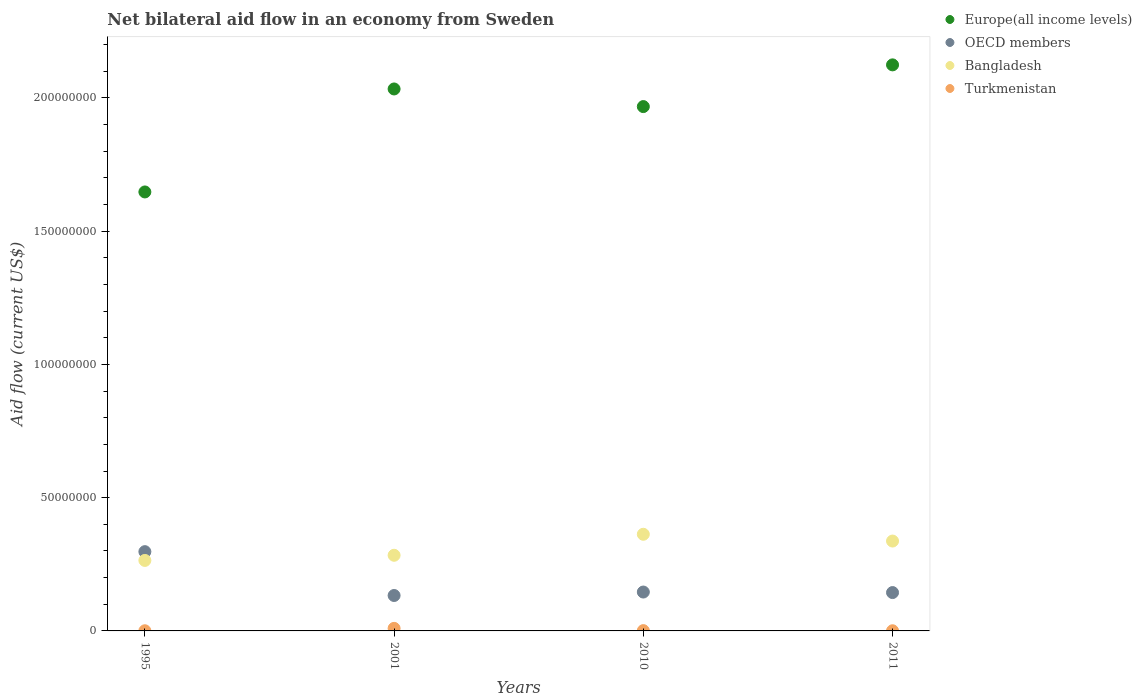Is the number of dotlines equal to the number of legend labels?
Give a very brief answer. Yes. What is the net bilateral aid flow in OECD members in 2010?
Make the answer very short. 1.46e+07. Across all years, what is the maximum net bilateral aid flow in Bangladesh?
Your answer should be very brief. 3.63e+07. Across all years, what is the minimum net bilateral aid flow in OECD members?
Give a very brief answer. 1.33e+07. What is the total net bilateral aid flow in Bangladesh in the graph?
Ensure brevity in your answer.  1.25e+08. What is the difference between the net bilateral aid flow in Europe(all income levels) in 1995 and that in 2010?
Your response must be concise. -3.20e+07. What is the difference between the net bilateral aid flow in Europe(all income levels) in 1995 and the net bilateral aid flow in OECD members in 2001?
Your response must be concise. 1.51e+08. What is the average net bilateral aid flow in OECD members per year?
Make the answer very short. 1.80e+07. In the year 2010, what is the difference between the net bilateral aid flow in Bangladesh and net bilateral aid flow in Turkmenistan?
Offer a terse response. 3.62e+07. What is the ratio of the net bilateral aid flow in Turkmenistan in 1995 to that in 2001?
Your response must be concise. 0.06. Is the net bilateral aid flow in Turkmenistan in 1995 less than that in 2001?
Keep it short and to the point. Yes. Is the difference between the net bilateral aid flow in Bangladesh in 2010 and 2011 greater than the difference between the net bilateral aid flow in Turkmenistan in 2010 and 2011?
Your answer should be compact. Yes. What is the difference between the highest and the second highest net bilateral aid flow in Europe(all income levels)?
Ensure brevity in your answer.  9.04e+06. What is the difference between the highest and the lowest net bilateral aid flow in Europe(all income levels)?
Provide a succinct answer. 4.77e+07. In how many years, is the net bilateral aid flow in Bangladesh greater than the average net bilateral aid flow in Bangladesh taken over all years?
Offer a terse response. 2. Is the sum of the net bilateral aid flow in OECD members in 2010 and 2011 greater than the maximum net bilateral aid flow in Bangladesh across all years?
Ensure brevity in your answer.  No. Is it the case that in every year, the sum of the net bilateral aid flow in Bangladesh and net bilateral aid flow in Europe(all income levels)  is greater than the net bilateral aid flow in OECD members?
Your answer should be compact. Yes. Is the net bilateral aid flow in OECD members strictly greater than the net bilateral aid flow in Bangladesh over the years?
Your response must be concise. No. How many dotlines are there?
Offer a terse response. 4. What is the difference between two consecutive major ticks on the Y-axis?
Keep it short and to the point. 5.00e+07. Where does the legend appear in the graph?
Ensure brevity in your answer.  Top right. How many legend labels are there?
Provide a succinct answer. 4. What is the title of the graph?
Ensure brevity in your answer.  Net bilateral aid flow in an economy from Sweden. What is the Aid flow (current US$) in Europe(all income levels) in 1995?
Offer a terse response. 1.65e+08. What is the Aid flow (current US$) of OECD members in 1995?
Your answer should be very brief. 2.97e+07. What is the Aid flow (current US$) in Bangladesh in 1995?
Make the answer very short. 2.64e+07. What is the Aid flow (current US$) of Europe(all income levels) in 2001?
Ensure brevity in your answer.  2.03e+08. What is the Aid flow (current US$) of OECD members in 2001?
Give a very brief answer. 1.33e+07. What is the Aid flow (current US$) of Bangladesh in 2001?
Ensure brevity in your answer.  2.84e+07. What is the Aid flow (current US$) of Turkmenistan in 2001?
Your response must be concise. 9.60e+05. What is the Aid flow (current US$) of Europe(all income levels) in 2010?
Your answer should be compact. 1.97e+08. What is the Aid flow (current US$) in OECD members in 2010?
Ensure brevity in your answer.  1.46e+07. What is the Aid flow (current US$) of Bangladesh in 2010?
Make the answer very short. 3.63e+07. What is the Aid flow (current US$) in Europe(all income levels) in 2011?
Keep it short and to the point. 2.12e+08. What is the Aid flow (current US$) in OECD members in 2011?
Offer a terse response. 1.44e+07. What is the Aid flow (current US$) of Bangladesh in 2011?
Provide a short and direct response. 3.37e+07. What is the Aid flow (current US$) of Turkmenistan in 2011?
Offer a terse response. 6.00e+04. Across all years, what is the maximum Aid flow (current US$) in Europe(all income levels)?
Your answer should be very brief. 2.12e+08. Across all years, what is the maximum Aid flow (current US$) in OECD members?
Your response must be concise. 2.97e+07. Across all years, what is the maximum Aid flow (current US$) in Bangladesh?
Give a very brief answer. 3.63e+07. Across all years, what is the maximum Aid flow (current US$) in Turkmenistan?
Give a very brief answer. 9.60e+05. Across all years, what is the minimum Aid flow (current US$) in Europe(all income levels)?
Offer a very short reply. 1.65e+08. Across all years, what is the minimum Aid flow (current US$) in OECD members?
Your response must be concise. 1.33e+07. Across all years, what is the minimum Aid flow (current US$) in Bangladesh?
Provide a short and direct response. 2.64e+07. Across all years, what is the minimum Aid flow (current US$) in Turkmenistan?
Your response must be concise. 6.00e+04. What is the total Aid flow (current US$) in Europe(all income levels) in the graph?
Your response must be concise. 7.77e+08. What is the total Aid flow (current US$) of OECD members in the graph?
Your answer should be very brief. 7.20e+07. What is the total Aid flow (current US$) in Bangladesh in the graph?
Ensure brevity in your answer.  1.25e+08. What is the total Aid flow (current US$) in Turkmenistan in the graph?
Offer a very short reply. 1.19e+06. What is the difference between the Aid flow (current US$) in Europe(all income levels) in 1995 and that in 2001?
Your response must be concise. -3.86e+07. What is the difference between the Aid flow (current US$) in OECD members in 1995 and that in 2001?
Offer a very short reply. 1.64e+07. What is the difference between the Aid flow (current US$) in Bangladesh in 1995 and that in 2001?
Your answer should be compact. -1.93e+06. What is the difference between the Aid flow (current US$) of Turkmenistan in 1995 and that in 2001?
Give a very brief answer. -9.00e+05. What is the difference between the Aid flow (current US$) of Europe(all income levels) in 1995 and that in 2010?
Give a very brief answer. -3.20e+07. What is the difference between the Aid flow (current US$) of OECD members in 1995 and that in 2010?
Your response must be concise. 1.52e+07. What is the difference between the Aid flow (current US$) in Bangladesh in 1995 and that in 2010?
Provide a succinct answer. -9.81e+06. What is the difference between the Aid flow (current US$) in Turkmenistan in 1995 and that in 2010?
Your answer should be very brief. -5.00e+04. What is the difference between the Aid flow (current US$) of Europe(all income levels) in 1995 and that in 2011?
Provide a short and direct response. -4.77e+07. What is the difference between the Aid flow (current US$) of OECD members in 1995 and that in 2011?
Ensure brevity in your answer.  1.54e+07. What is the difference between the Aid flow (current US$) in Bangladesh in 1995 and that in 2011?
Offer a very short reply. -7.27e+06. What is the difference between the Aid flow (current US$) of Europe(all income levels) in 2001 and that in 2010?
Ensure brevity in your answer.  6.61e+06. What is the difference between the Aid flow (current US$) in OECD members in 2001 and that in 2010?
Provide a short and direct response. -1.30e+06. What is the difference between the Aid flow (current US$) in Bangladesh in 2001 and that in 2010?
Offer a terse response. -7.88e+06. What is the difference between the Aid flow (current US$) in Turkmenistan in 2001 and that in 2010?
Give a very brief answer. 8.50e+05. What is the difference between the Aid flow (current US$) in Europe(all income levels) in 2001 and that in 2011?
Give a very brief answer. -9.04e+06. What is the difference between the Aid flow (current US$) of OECD members in 2001 and that in 2011?
Ensure brevity in your answer.  -1.10e+06. What is the difference between the Aid flow (current US$) in Bangladesh in 2001 and that in 2011?
Provide a succinct answer. -5.34e+06. What is the difference between the Aid flow (current US$) in Turkmenistan in 2001 and that in 2011?
Your answer should be very brief. 9.00e+05. What is the difference between the Aid flow (current US$) of Europe(all income levels) in 2010 and that in 2011?
Ensure brevity in your answer.  -1.56e+07. What is the difference between the Aid flow (current US$) of OECD members in 2010 and that in 2011?
Make the answer very short. 2.00e+05. What is the difference between the Aid flow (current US$) in Bangladesh in 2010 and that in 2011?
Give a very brief answer. 2.54e+06. What is the difference between the Aid flow (current US$) of Turkmenistan in 2010 and that in 2011?
Provide a short and direct response. 5.00e+04. What is the difference between the Aid flow (current US$) in Europe(all income levels) in 1995 and the Aid flow (current US$) in OECD members in 2001?
Provide a succinct answer. 1.51e+08. What is the difference between the Aid flow (current US$) in Europe(all income levels) in 1995 and the Aid flow (current US$) in Bangladesh in 2001?
Keep it short and to the point. 1.36e+08. What is the difference between the Aid flow (current US$) of Europe(all income levels) in 1995 and the Aid flow (current US$) of Turkmenistan in 2001?
Your answer should be compact. 1.64e+08. What is the difference between the Aid flow (current US$) in OECD members in 1995 and the Aid flow (current US$) in Bangladesh in 2001?
Your answer should be very brief. 1.36e+06. What is the difference between the Aid flow (current US$) in OECD members in 1995 and the Aid flow (current US$) in Turkmenistan in 2001?
Give a very brief answer. 2.88e+07. What is the difference between the Aid flow (current US$) in Bangladesh in 1995 and the Aid flow (current US$) in Turkmenistan in 2001?
Offer a terse response. 2.55e+07. What is the difference between the Aid flow (current US$) in Europe(all income levels) in 1995 and the Aid flow (current US$) in OECD members in 2010?
Offer a terse response. 1.50e+08. What is the difference between the Aid flow (current US$) of Europe(all income levels) in 1995 and the Aid flow (current US$) of Bangladesh in 2010?
Your answer should be compact. 1.28e+08. What is the difference between the Aid flow (current US$) of Europe(all income levels) in 1995 and the Aid flow (current US$) of Turkmenistan in 2010?
Provide a succinct answer. 1.65e+08. What is the difference between the Aid flow (current US$) of OECD members in 1995 and the Aid flow (current US$) of Bangladesh in 2010?
Make the answer very short. -6.52e+06. What is the difference between the Aid flow (current US$) of OECD members in 1995 and the Aid flow (current US$) of Turkmenistan in 2010?
Offer a very short reply. 2.96e+07. What is the difference between the Aid flow (current US$) in Bangladesh in 1995 and the Aid flow (current US$) in Turkmenistan in 2010?
Offer a very short reply. 2.63e+07. What is the difference between the Aid flow (current US$) in Europe(all income levels) in 1995 and the Aid flow (current US$) in OECD members in 2011?
Ensure brevity in your answer.  1.50e+08. What is the difference between the Aid flow (current US$) in Europe(all income levels) in 1995 and the Aid flow (current US$) in Bangladesh in 2011?
Your answer should be very brief. 1.31e+08. What is the difference between the Aid flow (current US$) in Europe(all income levels) in 1995 and the Aid flow (current US$) in Turkmenistan in 2011?
Offer a very short reply. 1.65e+08. What is the difference between the Aid flow (current US$) in OECD members in 1995 and the Aid flow (current US$) in Bangladesh in 2011?
Your response must be concise. -3.98e+06. What is the difference between the Aid flow (current US$) in OECD members in 1995 and the Aid flow (current US$) in Turkmenistan in 2011?
Your response must be concise. 2.97e+07. What is the difference between the Aid flow (current US$) in Bangladesh in 1995 and the Aid flow (current US$) in Turkmenistan in 2011?
Provide a short and direct response. 2.64e+07. What is the difference between the Aid flow (current US$) in Europe(all income levels) in 2001 and the Aid flow (current US$) in OECD members in 2010?
Make the answer very short. 1.89e+08. What is the difference between the Aid flow (current US$) in Europe(all income levels) in 2001 and the Aid flow (current US$) in Bangladesh in 2010?
Make the answer very short. 1.67e+08. What is the difference between the Aid flow (current US$) in Europe(all income levels) in 2001 and the Aid flow (current US$) in Turkmenistan in 2010?
Ensure brevity in your answer.  2.03e+08. What is the difference between the Aid flow (current US$) in OECD members in 2001 and the Aid flow (current US$) in Bangladesh in 2010?
Ensure brevity in your answer.  -2.30e+07. What is the difference between the Aid flow (current US$) in OECD members in 2001 and the Aid flow (current US$) in Turkmenistan in 2010?
Provide a short and direct response. 1.32e+07. What is the difference between the Aid flow (current US$) of Bangladesh in 2001 and the Aid flow (current US$) of Turkmenistan in 2010?
Provide a succinct answer. 2.83e+07. What is the difference between the Aid flow (current US$) of Europe(all income levels) in 2001 and the Aid flow (current US$) of OECD members in 2011?
Provide a short and direct response. 1.89e+08. What is the difference between the Aid flow (current US$) of Europe(all income levels) in 2001 and the Aid flow (current US$) of Bangladesh in 2011?
Keep it short and to the point. 1.70e+08. What is the difference between the Aid flow (current US$) in Europe(all income levels) in 2001 and the Aid flow (current US$) in Turkmenistan in 2011?
Provide a succinct answer. 2.03e+08. What is the difference between the Aid flow (current US$) of OECD members in 2001 and the Aid flow (current US$) of Bangladesh in 2011?
Provide a short and direct response. -2.04e+07. What is the difference between the Aid flow (current US$) of OECD members in 2001 and the Aid flow (current US$) of Turkmenistan in 2011?
Your answer should be very brief. 1.32e+07. What is the difference between the Aid flow (current US$) in Bangladesh in 2001 and the Aid flow (current US$) in Turkmenistan in 2011?
Your answer should be very brief. 2.83e+07. What is the difference between the Aid flow (current US$) of Europe(all income levels) in 2010 and the Aid flow (current US$) of OECD members in 2011?
Ensure brevity in your answer.  1.82e+08. What is the difference between the Aid flow (current US$) of Europe(all income levels) in 2010 and the Aid flow (current US$) of Bangladesh in 2011?
Give a very brief answer. 1.63e+08. What is the difference between the Aid flow (current US$) in Europe(all income levels) in 2010 and the Aid flow (current US$) in Turkmenistan in 2011?
Your answer should be very brief. 1.97e+08. What is the difference between the Aid flow (current US$) of OECD members in 2010 and the Aid flow (current US$) of Bangladesh in 2011?
Ensure brevity in your answer.  -1.91e+07. What is the difference between the Aid flow (current US$) in OECD members in 2010 and the Aid flow (current US$) in Turkmenistan in 2011?
Your answer should be very brief. 1.45e+07. What is the difference between the Aid flow (current US$) in Bangladesh in 2010 and the Aid flow (current US$) in Turkmenistan in 2011?
Offer a very short reply. 3.62e+07. What is the average Aid flow (current US$) in Europe(all income levels) per year?
Your answer should be compact. 1.94e+08. What is the average Aid flow (current US$) of OECD members per year?
Ensure brevity in your answer.  1.80e+07. What is the average Aid flow (current US$) in Bangladesh per year?
Make the answer very short. 3.12e+07. What is the average Aid flow (current US$) in Turkmenistan per year?
Keep it short and to the point. 2.98e+05. In the year 1995, what is the difference between the Aid flow (current US$) of Europe(all income levels) and Aid flow (current US$) of OECD members?
Keep it short and to the point. 1.35e+08. In the year 1995, what is the difference between the Aid flow (current US$) in Europe(all income levels) and Aid flow (current US$) in Bangladesh?
Provide a short and direct response. 1.38e+08. In the year 1995, what is the difference between the Aid flow (current US$) of Europe(all income levels) and Aid flow (current US$) of Turkmenistan?
Provide a short and direct response. 1.65e+08. In the year 1995, what is the difference between the Aid flow (current US$) of OECD members and Aid flow (current US$) of Bangladesh?
Offer a very short reply. 3.29e+06. In the year 1995, what is the difference between the Aid flow (current US$) of OECD members and Aid flow (current US$) of Turkmenistan?
Ensure brevity in your answer.  2.97e+07. In the year 1995, what is the difference between the Aid flow (current US$) in Bangladesh and Aid flow (current US$) in Turkmenistan?
Keep it short and to the point. 2.64e+07. In the year 2001, what is the difference between the Aid flow (current US$) of Europe(all income levels) and Aid flow (current US$) of OECD members?
Provide a short and direct response. 1.90e+08. In the year 2001, what is the difference between the Aid flow (current US$) of Europe(all income levels) and Aid flow (current US$) of Bangladesh?
Keep it short and to the point. 1.75e+08. In the year 2001, what is the difference between the Aid flow (current US$) in Europe(all income levels) and Aid flow (current US$) in Turkmenistan?
Offer a very short reply. 2.02e+08. In the year 2001, what is the difference between the Aid flow (current US$) of OECD members and Aid flow (current US$) of Bangladesh?
Provide a short and direct response. -1.51e+07. In the year 2001, what is the difference between the Aid flow (current US$) in OECD members and Aid flow (current US$) in Turkmenistan?
Ensure brevity in your answer.  1.23e+07. In the year 2001, what is the difference between the Aid flow (current US$) in Bangladesh and Aid flow (current US$) in Turkmenistan?
Ensure brevity in your answer.  2.74e+07. In the year 2010, what is the difference between the Aid flow (current US$) of Europe(all income levels) and Aid flow (current US$) of OECD members?
Make the answer very short. 1.82e+08. In the year 2010, what is the difference between the Aid flow (current US$) in Europe(all income levels) and Aid flow (current US$) in Bangladesh?
Provide a short and direct response. 1.60e+08. In the year 2010, what is the difference between the Aid flow (current US$) of Europe(all income levels) and Aid flow (current US$) of Turkmenistan?
Provide a short and direct response. 1.97e+08. In the year 2010, what is the difference between the Aid flow (current US$) in OECD members and Aid flow (current US$) in Bangladesh?
Provide a short and direct response. -2.17e+07. In the year 2010, what is the difference between the Aid flow (current US$) of OECD members and Aid flow (current US$) of Turkmenistan?
Provide a short and direct response. 1.45e+07. In the year 2010, what is the difference between the Aid flow (current US$) of Bangladesh and Aid flow (current US$) of Turkmenistan?
Your answer should be very brief. 3.62e+07. In the year 2011, what is the difference between the Aid flow (current US$) in Europe(all income levels) and Aid flow (current US$) in OECD members?
Ensure brevity in your answer.  1.98e+08. In the year 2011, what is the difference between the Aid flow (current US$) in Europe(all income levels) and Aid flow (current US$) in Bangladesh?
Offer a very short reply. 1.79e+08. In the year 2011, what is the difference between the Aid flow (current US$) in Europe(all income levels) and Aid flow (current US$) in Turkmenistan?
Your answer should be very brief. 2.12e+08. In the year 2011, what is the difference between the Aid flow (current US$) of OECD members and Aid flow (current US$) of Bangladesh?
Your response must be concise. -1.93e+07. In the year 2011, what is the difference between the Aid flow (current US$) of OECD members and Aid flow (current US$) of Turkmenistan?
Your response must be concise. 1.43e+07. In the year 2011, what is the difference between the Aid flow (current US$) of Bangladesh and Aid flow (current US$) of Turkmenistan?
Make the answer very short. 3.37e+07. What is the ratio of the Aid flow (current US$) of Europe(all income levels) in 1995 to that in 2001?
Give a very brief answer. 0.81. What is the ratio of the Aid flow (current US$) of OECD members in 1995 to that in 2001?
Make the answer very short. 2.24. What is the ratio of the Aid flow (current US$) of Bangladesh in 1995 to that in 2001?
Provide a short and direct response. 0.93. What is the ratio of the Aid flow (current US$) in Turkmenistan in 1995 to that in 2001?
Your answer should be compact. 0.06. What is the ratio of the Aid flow (current US$) of Europe(all income levels) in 1995 to that in 2010?
Give a very brief answer. 0.84. What is the ratio of the Aid flow (current US$) in OECD members in 1995 to that in 2010?
Provide a short and direct response. 2.04. What is the ratio of the Aid flow (current US$) of Bangladesh in 1995 to that in 2010?
Your answer should be very brief. 0.73. What is the ratio of the Aid flow (current US$) of Turkmenistan in 1995 to that in 2010?
Provide a succinct answer. 0.55. What is the ratio of the Aid flow (current US$) of Europe(all income levels) in 1995 to that in 2011?
Offer a terse response. 0.78. What is the ratio of the Aid flow (current US$) in OECD members in 1995 to that in 2011?
Give a very brief answer. 2.07. What is the ratio of the Aid flow (current US$) in Bangladesh in 1995 to that in 2011?
Offer a very short reply. 0.78. What is the ratio of the Aid flow (current US$) in Europe(all income levels) in 2001 to that in 2010?
Offer a terse response. 1.03. What is the ratio of the Aid flow (current US$) of OECD members in 2001 to that in 2010?
Your answer should be compact. 0.91. What is the ratio of the Aid flow (current US$) of Bangladesh in 2001 to that in 2010?
Ensure brevity in your answer.  0.78. What is the ratio of the Aid flow (current US$) in Turkmenistan in 2001 to that in 2010?
Offer a terse response. 8.73. What is the ratio of the Aid flow (current US$) of Europe(all income levels) in 2001 to that in 2011?
Give a very brief answer. 0.96. What is the ratio of the Aid flow (current US$) in OECD members in 2001 to that in 2011?
Keep it short and to the point. 0.92. What is the ratio of the Aid flow (current US$) of Bangladesh in 2001 to that in 2011?
Ensure brevity in your answer.  0.84. What is the ratio of the Aid flow (current US$) of Turkmenistan in 2001 to that in 2011?
Keep it short and to the point. 16. What is the ratio of the Aid flow (current US$) in Europe(all income levels) in 2010 to that in 2011?
Keep it short and to the point. 0.93. What is the ratio of the Aid flow (current US$) of OECD members in 2010 to that in 2011?
Offer a very short reply. 1.01. What is the ratio of the Aid flow (current US$) in Bangladesh in 2010 to that in 2011?
Offer a terse response. 1.08. What is the ratio of the Aid flow (current US$) of Turkmenistan in 2010 to that in 2011?
Your response must be concise. 1.83. What is the difference between the highest and the second highest Aid flow (current US$) in Europe(all income levels)?
Ensure brevity in your answer.  9.04e+06. What is the difference between the highest and the second highest Aid flow (current US$) in OECD members?
Ensure brevity in your answer.  1.52e+07. What is the difference between the highest and the second highest Aid flow (current US$) of Bangladesh?
Your answer should be compact. 2.54e+06. What is the difference between the highest and the second highest Aid flow (current US$) of Turkmenistan?
Keep it short and to the point. 8.50e+05. What is the difference between the highest and the lowest Aid flow (current US$) of Europe(all income levels)?
Your answer should be compact. 4.77e+07. What is the difference between the highest and the lowest Aid flow (current US$) in OECD members?
Offer a very short reply. 1.64e+07. What is the difference between the highest and the lowest Aid flow (current US$) in Bangladesh?
Offer a terse response. 9.81e+06. 